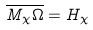Convert formula to latex. <formula><loc_0><loc_0><loc_500><loc_500>\overline { M _ { \chi } \Omega } = H _ { \chi }</formula> 